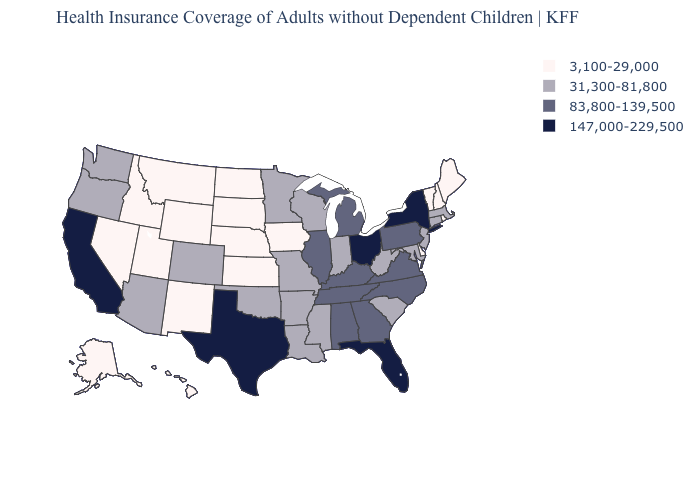Does North Dakota have the lowest value in the USA?
Concise answer only. Yes. What is the value of North Dakota?
Keep it brief. 3,100-29,000. Does the map have missing data?
Answer briefly. No. What is the value of Tennessee?
Short answer required. 83,800-139,500. Does Georgia have a higher value than Texas?
Answer briefly. No. Name the states that have a value in the range 83,800-139,500?
Be succinct. Alabama, Georgia, Illinois, Kentucky, Michigan, North Carolina, Pennsylvania, Tennessee, Virginia. Does Iowa have the lowest value in the USA?
Concise answer only. Yes. Name the states that have a value in the range 31,300-81,800?
Keep it brief. Arizona, Arkansas, Colorado, Connecticut, Indiana, Louisiana, Maryland, Massachusetts, Minnesota, Mississippi, Missouri, New Jersey, Oklahoma, Oregon, South Carolina, Washington, West Virginia, Wisconsin. What is the lowest value in the USA?
Give a very brief answer. 3,100-29,000. Does the first symbol in the legend represent the smallest category?
Answer briefly. Yes. What is the value of Iowa?
Give a very brief answer. 3,100-29,000. Name the states that have a value in the range 147,000-229,500?
Quick response, please. California, Florida, New York, Ohio, Texas. Name the states that have a value in the range 147,000-229,500?
Quick response, please. California, Florida, New York, Ohio, Texas. Is the legend a continuous bar?
Give a very brief answer. No. Name the states that have a value in the range 83,800-139,500?
Concise answer only. Alabama, Georgia, Illinois, Kentucky, Michigan, North Carolina, Pennsylvania, Tennessee, Virginia. 